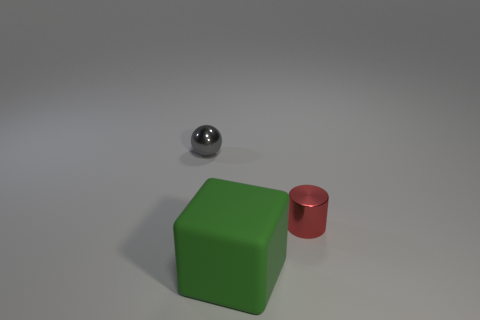Is there any other thing that has the same shape as the big green thing?
Offer a terse response. No. The cylinder has what color?
Provide a succinct answer. Red. Does the sphere behind the red shiny object have the same size as the big matte object?
Give a very brief answer. No. What material is the tiny thing that is on the right side of the tiny thing that is left of the metallic object that is in front of the gray metal object?
Offer a terse response. Metal. There is a tiny object that is on the left side of the rubber block; does it have the same color as the thing that is on the right side of the large matte block?
Provide a succinct answer. No. The tiny thing in front of the tiny object behind the shiny cylinder is made of what material?
Your answer should be very brief. Metal. What color is the thing that is the same size as the red cylinder?
Your response must be concise. Gray. What number of small balls are behind the small shiny thing that is in front of the tiny object behind the cylinder?
Your response must be concise. 1. How big is the metal thing to the right of the big green rubber object to the right of the tiny metallic ball?
Your response must be concise. Small. The other thing that is made of the same material as the red object is what size?
Your answer should be compact. Small. 